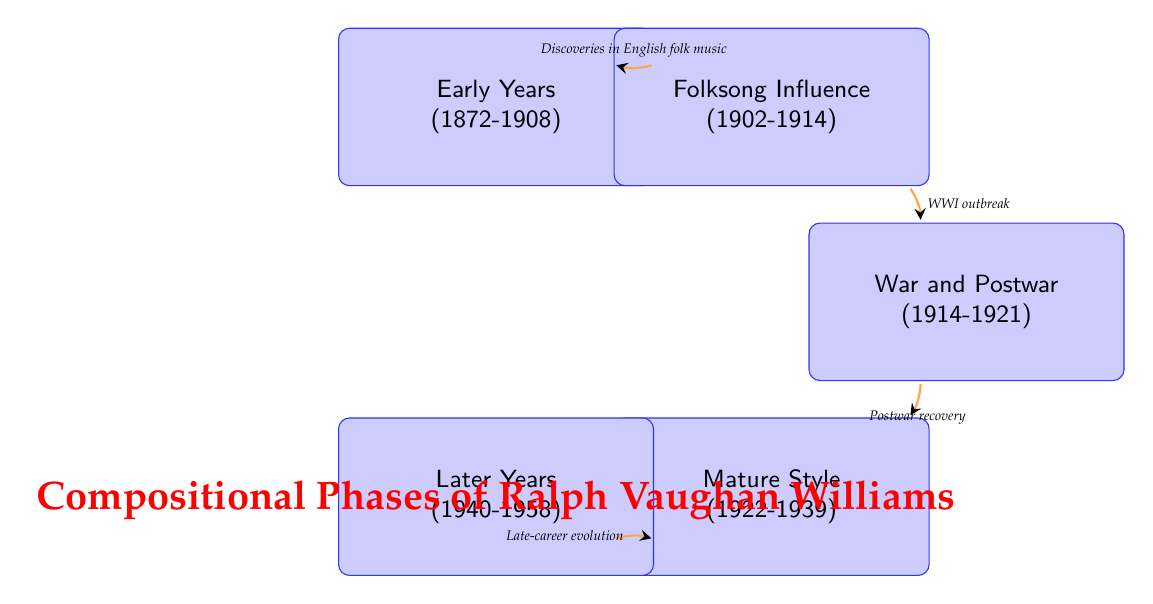What is the first compositional phase in the diagram? The first state in the diagram is "Early Years," which is indicated as the starting point of Vaughan Williams's compositional phases.
Answer: Early Years How many compositional phases are represented in the diagram? The diagram includes a total of five defined states, each representing different phases in Vaughan Williams's compositional timeline.
Answer: 5 What year range does the "Folksong Influence" phase cover? The "Folksong Influence" phase is labeled with the year range of 1902-1914, as shown in the corresponding state box.
Answer: 1902-1914 Which two phases directly connect the impact of WWI? The connection from "Folksong Influence" to "War and Postwar" signifies the direct impact of WWI on Vaughan Williams's music, reflecting the historical context of the transition.
Answer: Folksong Influence and War and Postwar What is the theme of the "War and Postwar" phase? The description states that this phase is characterized by introspective and somber themes due to the impacts of WWI and its aftermath, which is indicated in the node's information.
Answer: Introspective and somber themes Which phase follows the "Mature Style" phase? The transition indicated from "Mature Style" leads to "Later Years," as shown by the arrow pointing to the next state in the sequence.
Answer: Later Years What influences the transition from "Early Years" to "Folksong Influence"? The diagram specifies that this transition is influenced by Vaughan Williams's profound discoveries of English folk music, making it a pivotal moment in his development.
Answer: Discoveries in English folk music What characterizes the compositions in the "Later Years"? The "Later Years" phase is described as exhibiting advanced techniques and a continuous evolution of Vaughan Williams's musical voice, often reflecting on mortality and legacy.
Answer: Advanced techniques and reflection on mortality and legacy What drives the transition from "War and Postwar" to "Mature Style"? This transition is marked by the recovery following WWI, indicating a shift towards a more mature compositional style in Vaughan Williams's works.
Answer: Postwar recovery 